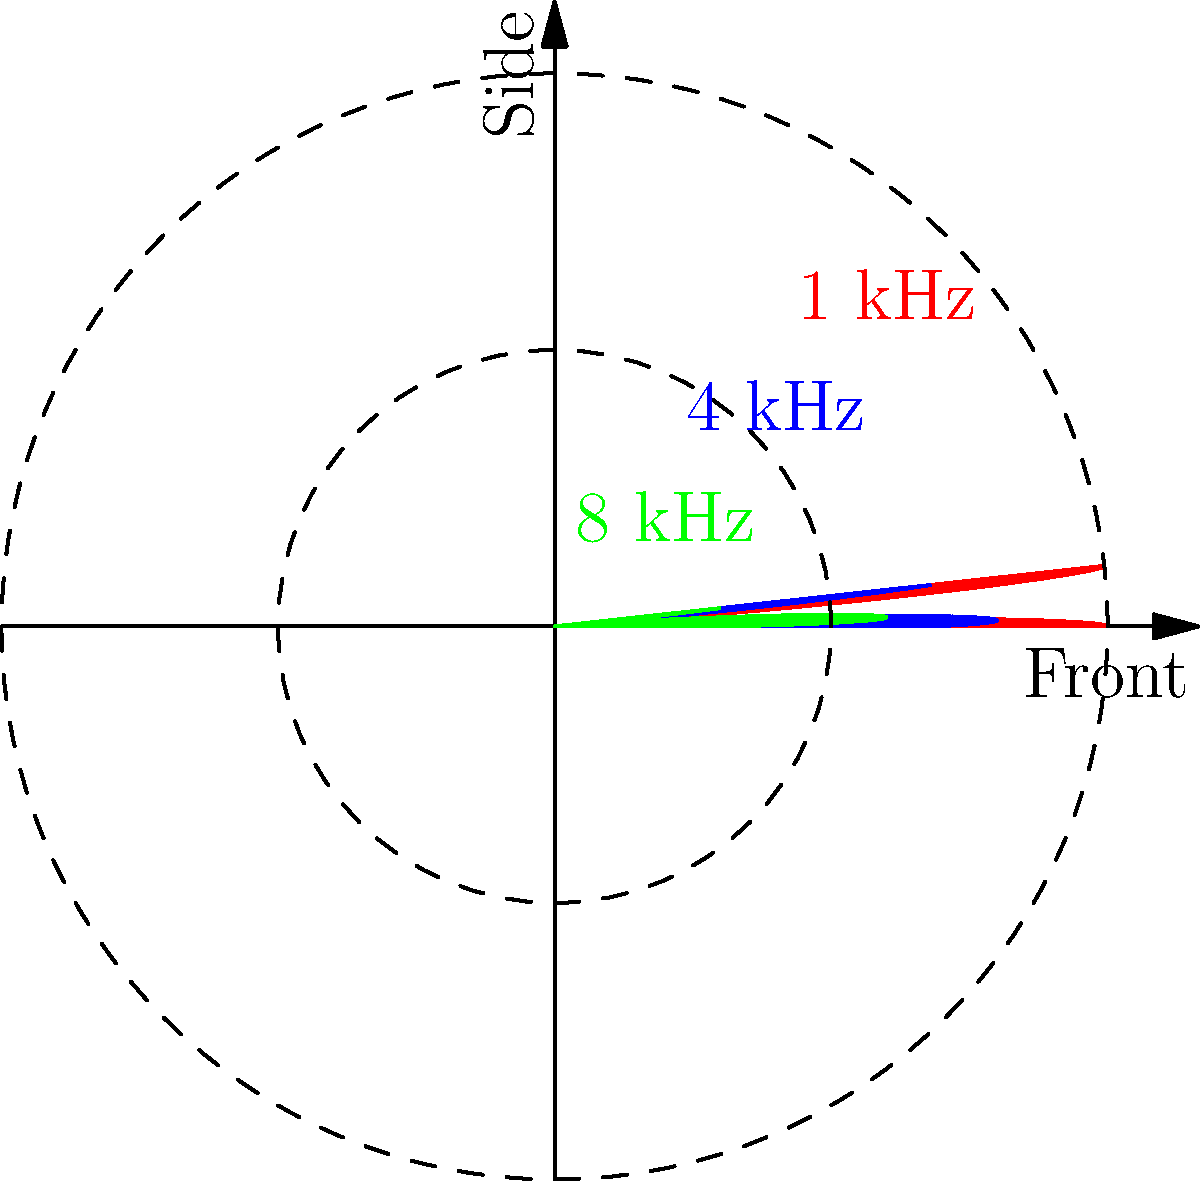In designing a soundscape for a horror-themed attraction, you're considering using a cardioid microphone. The polar pattern of this microphone at different frequencies is shown above. What phenomenon does this graph illustrate about the microphone's directional sensitivity as frequency increases? To answer this question, let's analyze the polar patterns shown in the graph:

1. The red curve represents the microphone's polar pattern at 1 kHz. It shows a typical cardioid pattern with maximum sensitivity at the front (0°) and minimum at the rear (180°).

2. The blue curve represents the pattern at 4 kHz. Compared to the 1 kHz pattern, it's slightly narrower and more directional.

3. The green curve represents the pattern at 8 kHz. This pattern is even narrower and more directional than the 4 kHz pattern.

4. As we move from lower to higher frequencies (red to blue to green), we can observe that:
   a) The main lobe (front direction) becomes narrower.
   b) The sensitivity to off-axis sounds (sides and rear) decreases.

This phenomenon is known as "narrowing of the polar pattern" or "increased directionality at higher frequencies." It occurs because higher frequency sound waves have shorter wavelengths, which interact differently with the microphone's physical structure and acoustic design.

For a horror-themed attraction, this characteristic could be useful for:
- Focusing on specific sound sources while rejecting ambient noise
- Creating more precise spatial audio effects
- Potentially reducing feedback in live sound situations

However, it also means that the microphone's off-axis frequency response may not be as flat, which could affect the tonal balance of sounds coming from different directions.
Answer: Increased directionality at higher frequencies 